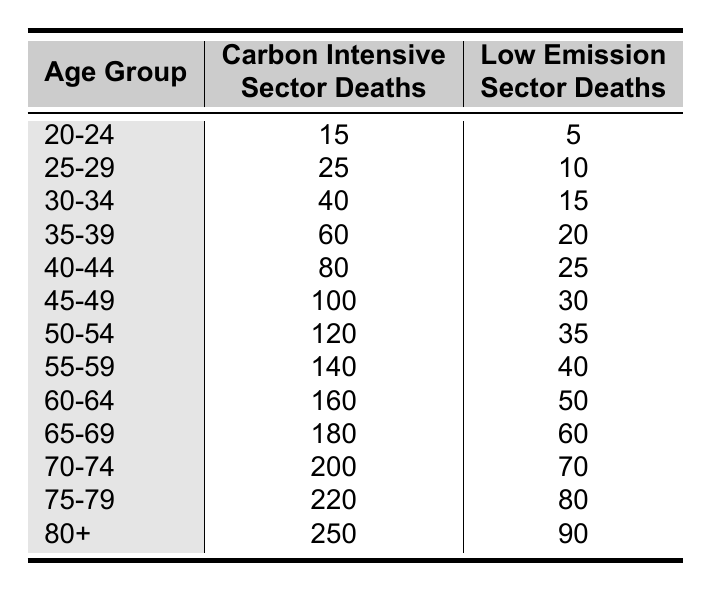What is the number of deaths in the carbon-intensive sector for the age group 35-39? The age group 35-39 in the table shows that there were 60 deaths in the carbon-intensive sector.
Answer: 60 What is the number of deaths in the low-emission sector for the age group 50-54? According to the table, the age group 50-54 has 35 deaths in the low-emission sector.
Answer: 35 Which age group has the highest number of deaths in the carbon-intensive sector? The table indicates that the age group 80+ has the highest number of deaths, totaling 250 in the carbon-intensive sector.
Answer: 80+ Is the number of deaths in the carbon-intensive sector for the age group 60-64 greater than the deaths in the low-emission sector for the age group 55-59? The carbon-intensive sector has 160 deaths for the age group 60-64 and 40 deaths in the low-emission sector for the age group 55-59. Since 160 is greater than 40, the statement is true.
Answer: Yes What is the total number of deaths in the low-emission sector for all age groups combined? To find this, we add all the deaths in the low-emission sector: 5 + 10 + 15 + 20 + 25 + 30 + 35 + 40 + 50 + 60 + 70 + 80 + 90 = 450.
Answer: 450 What is the difference in the number of deaths between the carbon-intensive and low-emission sectors for the age group 45-49? For the age group 45-49, the carbon-intensive sector has 100 deaths and the low-emission sector has 30 deaths. The difference is calculated as 100 - 30 = 70.
Answer: 70 What age group has a lower number of deaths in the low-emission sector, 25-29 or 30-34? The age group 25-29 has 10 deaths in the low-emission sector, while the age group 30-34 has 15 deaths. Since 10 is less than 15, the age group 25-29 has lower deaths in the low-emission sector.
Answer: 25-29 What is the total number of deaths for the age group 75-79 across both sectors? To find the total for the age group 75-79, we add 220 (carbon-intensive sector) and 80 (low-emission sector), which is 220 + 80 = 300.
Answer: 300 Are there more deaths in the carbon-intensive sector for the age group 70-74 than in the low-emission sector for the age group 60-64? The age group 70-74 has 200 deaths in the carbon-intensive sector, and age group 60-64 has 50 deaths in the low-emission sector. Since 200 is greater than 50, the statement is true.
Answer: Yes 